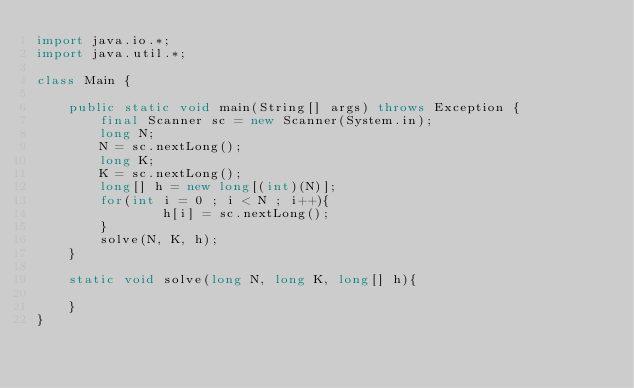Convert code to text. <code><loc_0><loc_0><loc_500><loc_500><_Java_>import java.io.*;
import java.util.*;

class Main {

    public static void main(String[] args) throws Exception {
        final Scanner sc = new Scanner(System.in);
        long N;
        N = sc.nextLong();
        long K;
        K = sc.nextLong();
        long[] h = new long[(int)(N)];
        for(int i = 0 ; i < N ; i++){
                h[i] = sc.nextLong();
        }
        solve(N, K, h);
    }

    static void solve(long N, long K, long[] h){

    }
}
</code> 